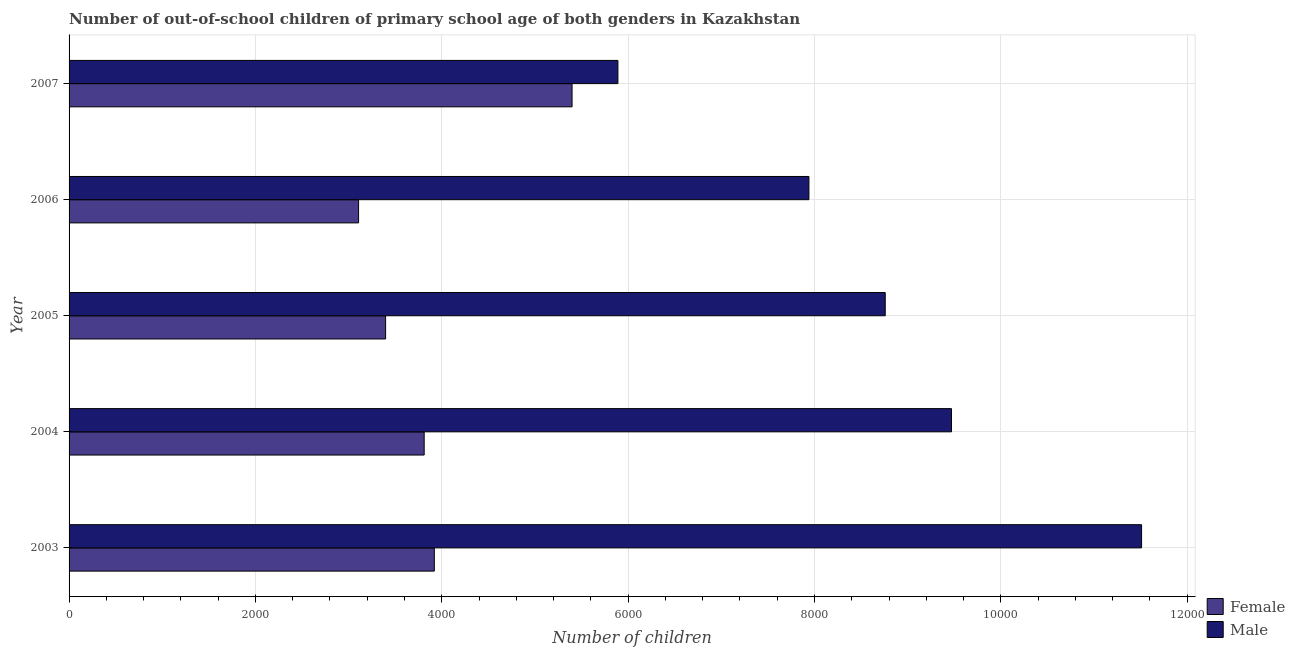How many different coloured bars are there?
Your response must be concise. 2. How many groups of bars are there?
Your answer should be compact. 5. Are the number of bars on each tick of the Y-axis equal?
Offer a terse response. Yes. How many bars are there on the 4th tick from the top?
Your response must be concise. 2. How many bars are there on the 1st tick from the bottom?
Give a very brief answer. 2. In how many cases, is the number of bars for a given year not equal to the number of legend labels?
Provide a short and direct response. 0. What is the number of male out-of-school students in 2005?
Make the answer very short. 8759. Across all years, what is the maximum number of female out-of-school students?
Make the answer very short. 5398. Across all years, what is the minimum number of female out-of-school students?
Offer a very short reply. 3107. In which year was the number of female out-of-school students maximum?
Offer a terse response. 2007. In which year was the number of male out-of-school students minimum?
Keep it short and to the point. 2007. What is the total number of female out-of-school students in the graph?
Provide a short and direct response. 1.96e+04. What is the difference between the number of female out-of-school students in 2003 and that in 2004?
Give a very brief answer. 109. What is the difference between the number of female out-of-school students in 2005 and the number of male out-of-school students in 2003?
Provide a succinct answer. -8113. What is the average number of female out-of-school students per year?
Your answer should be very brief. 3926.6. In the year 2003, what is the difference between the number of male out-of-school students and number of female out-of-school students?
Offer a terse response. 7590. In how many years, is the number of female out-of-school students greater than 10400 ?
Provide a succinct answer. 0. What is the ratio of the number of male out-of-school students in 2004 to that in 2005?
Your response must be concise. 1.08. Is the number of male out-of-school students in 2005 less than that in 2006?
Give a very brief answer. No. What is the difference between the highest and the second highest number of female out-of-school students?
Offer a very short reply. 1478. What is the difference between the highest and the lowest number of male out-of-school students?
Ensure brevity in your answer.  5620. In how many years, is the number of male out-of-school students greater than the average number of male out-of-school students taken over all years?
Provide a succinct answer. 3. Is the sum of the number of female out-of-school students in 2005 and 2007 greater than the maximum number of male out-of-school students across all years?
Provide a succinct answer. No. What is the difference between two consecutive major ticks on the X-axis?
Give a very brief answer. 2000. How many legend labels are there?
Your response must be concise. 2. How are the legend labels stacked?
Give a very brief answer. Vertical. What is the title of the graph?
Keep it short and to the point. Number of out-of-school children of primary school age of both genders in Kazakhstan. What is the label or title of the X-axis?
Make the answer very short. Number of children. What is the label or title of the Y-axis?
Ensure brevity in your answer.  Year. What is the Number of children of Female in 2003?
Provide a succinct answer. 3920. What is the Number of children in Male in 2003?
Make the answer very short. 1.15e+04. What is the Number of children in Female in 2004?
Offer a very short reply. 3811. What is the Number of children of Male in 2004?
Keep it short and to the point. 9470. What is the Number of children of Female in 2005?
Your response must be concise. 3397. What is the Number of children of Male in 2005?
Keep it short and to the point. 8759. What is the Number of children in Female in 2006?
Your response must be concise. 3107. What is the Number of children of Male in 2006?
Offer a very short reply. 7940. What is the Number of children of Female in 2007?
Keep it short and to the point. 5398. What is the Number of children in Male in 2007?
Offer a very short reply. 5890. Across all years, what is the maximum Number of children in Female?
Your response must be concise. 5398. Across all years, what is the maximum Number of children of Male?
Provide a succinct answer. 1.15e+04. Across all years, what is the minimum Number of children of Female?
Make the answer very short. 3107. Across all years, what is the minimum Number of children in Male?
Provide a short and direct response. 5890. What is the total Number of children of Female in the graph?
Give a very brief answer. 1.96e+04. What is the total Number of children of Male in the graph?
Your response must be concise. 4.36e+04. What is the difference between the Number of children of Female in 2003 and that in 2004?
Your answer should be very brief. 109. What is the difference between the Number of children in Male in 2003 and that in 2004?
Give a very brief answer. 2040. What is the difference between the Number of children in Female in 2003 and that in 2005?
Keep it short and to the point. 523. What is the difference between the Number of children of Male in 2003 and that in 2005?
Make the answer very short. 2751. What is the difference between the Number of children of Female in 2003 and that in 2006?
Your answer should be very brief. 813. What is the difference between the Number of children of Male in 2003 and that in 2006?
Ensure brevity in your answer.  3570. What is the difference between the Number of children in Female in 2003 and that in 2007?
Provide a short and direct response. -1478. What is the difference between the Number of children in Male in 2003 and that in 2007?
Provide a short and direct response. 5620. What is the difference between the Number of children of Female in 2004 and that in 2005?
Your answer should be compact. 414. What is the difference between the Number of children of Male in 2004 and that in 2005?
Your answer should be compact. 711. What is the difference between the Number of children in Female in 2004 and that in 2006?
Provide a succinct answer. 704. What is the difference between the Number of children in Male in 2004 and that in 2006?
Make the answer very short. 1530. What is the difference between the Number of children of Female in 2004 and that in 2007?
Your answer should be compact. -1587. What is the difference between the Number of children of Male in 2004 and that in 2007?
Your answer should be very brief. 3580. What is the difference between the Number of children in Female in 2005 and that in 2006?
Give a very brief answer. 290. What is the difference between the Number of children of Male in 2005 and that in 2006?
Your answer should be compact. 819. What is the difference between the Number of children of Female in 2005 and that in 2007?
Offer a terse response. -2001. What is the difference between the Number of children of Male in 2005 and that in 2007?
Provide a short and direct response. 2869. What is the difference between the Number of children in Female in 2006 and that in 2007?
Your answer should be compact. -2291. What is the difference between the Number of children of Male in 2006 and that in 2007?
Offer a terse response. 2050. What is the difference between the Number of children in Female in 2003 and the Number of children in Male in 2004?
Provide a short and direct response. -5550. What is the difference between the Number of children of Female in 2003 and the Number of children of Male in 2005?
Your answer should be very brief. -4839. What is the difference between the Number of children of Female in 2003 and the Number of children of Male in 2006?
Give a very brief answer. -4020. What is the difference between the Number of children in Female in 2003 and the Number of children in Male in 2007?
Ensure brevity in your answer.  -1970. What is the difference between the Number of children in Female in 2004 and the Number of children in Male in 2005?
Your answer should be very brief. -4948. What is the difference between the Number of children of Female in 2004 and the Number of children of Male in 2006?
Offer a terse response. -4129. What is the difference between the Number of children in Female in 2004 and the Number of children in Male in 2007?
Keep it short and to the point. -2079. What is the difference between the Number of children in Female in 2005 and the Number of children in Male in 2006?
Ensure brevity in your answer.  -4543. What is the difference between the Number of children in Female in 2005 and the Number of children in Male in 2007?
Your response must be concise. -2493. What is the difference between the Number of children of Female in 2006 and the Number of children of Male in 2007?
Make the answer very short. -2783. What is the average Number of children of Female per year?
Provide a succinct answer. 3926.6. What is the average Number of children in Male per year?
Provide a succinct answer. 8713.8. In the year 2003, what is the difference between the Number of children in Female and Number of children in Male?
Make the answer very short. -7590. In the year 2004, what is the difference between the Number of children in Female and Number of children in Male?
Offer a very short reply. -5659. In the year 2005, what is the difference between the Number of children of Female and Number of children of Male?
Offer a terse response. -5362. In the year 2006, what is the difference between the Number of children in Female and Number of children in Male?
Provide a succinct answer. -4833. In the year 2007, what is the difference between the Number of children of Female and Number of children of Male?
Give a very brief answer. -492. What is the ratio of the Number of children in Female in 2003 to that in 2004?
Offer a very short reply. 1.03. What is the ratio of the Number of children in Male in 2003 to that in 2004?
Make the answer very short. 1.22. What is the ratio of the Number of children of Female in 2003 to that in 2005?
Make the answer very short. 1.15. What is the ratio of the Number of children in Male in 2003 to that in 2005?
Make the answer very short. 1.31. What is the ratio of the Number of children in Female in 2003 to that in 2006?
Keep it short and to the point. 1.26. What is the ratio of the Number of children of Male in 2003 to that in 2006?
Ensure brevity in your answer.  1.45. What is the ratio of the Number of children in Female in 2003 to that in 2007?
Keep it short and to the point. 0.73. What is the ratio of the Number of children in Male in 2003 to that in 2007?
Your answer should be very brief. 1.95. What is the ratio of the Number of children in Female in 2004 to that in 2005?
Ensure brevity in your answer.  1.12. What is the ratio of the Number of children in Male in 2004 to that in 2005?
Provide a succinct answer. 1.08. What is the ratio of the Number of children in Female in 2004 to that in 2006?
Your response must be concise. 1.23. What is the ratio of the Number of children of Male in 2004 to that in 2006?
Your response must be concise. 1.19. What is the ratio of the Number of children of Female in 2004 to that in 2007?
Offer a very short reply. 0.71. What is the ratio of the Number of children of Male in 2004 to that in 2007?
Offer a very short reply. 1.61. What is the ratio of the Number of children in Female in 2005 to that in 2006?
Make the answer very short. 1.09. What is the ratio of the Number of children of Male in 2005 to that in 2006?
Make the answer very short. 1.1. What is the ratio of the Number of children in Female in 2005 to that in 2007?
Ensure brevity in your answer.  0.63. What is the ratio of the Number of children of Male in 2005 to that in 2007?
Keep it short and to the point. 1.49. What is the ratio of the Number of children in Female in 2006 to that in 2007?
Keep it short and to the point. 0.58. What is the ratio of the Number of children in Male in 2006 to that in 2007?
Provide a succinct answer. 1.35. What is the difference between the highest and the second highest Number of children of Female?
Your answer should be very brief. 1478. What is the difference between the highest and the second highest Number of children in Male?
Your answer should be very brief. 2040. What is the difference between the highest and the lowest Number of children in Female?
Provide a succinct answer. 2291. What is the difference between the highest and the lowest Number of children in Male?
Your answer should be very brief. 5620. 